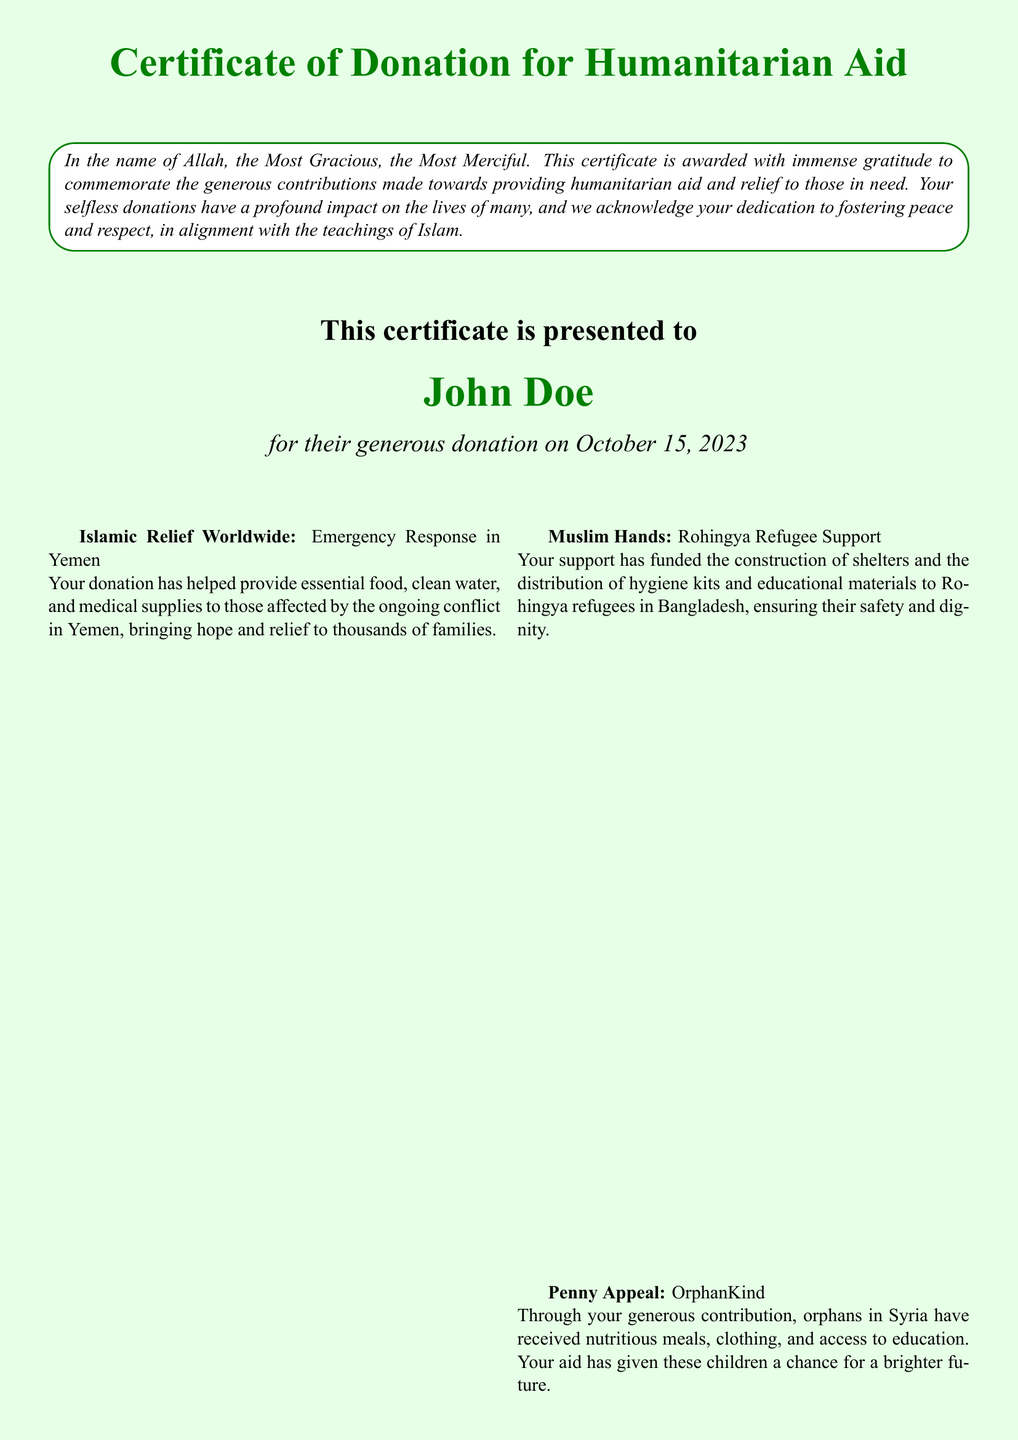What is the title of the certificate? The title of the certificate is stated at the top of the document.
Answer: Certificate of Donation for Humanitarian Aid Who is the certificate presented to? The recipient of the certificate is specified in the document.
Answer: John Doe What is the date of the donation? The date when the donation was made is mentioned in the certificate.
Answer: October 15, 2023 Which organization provided emergency response in Yemen? The document lists organizations involved in various humanitarian projects, including one for Yemen.
Answer: Islamic Relief Worldwide What project did Muslim Hands support? The document details specific humanitarian projects supported by donations.
Answer: Rohingya Refugee Support What type of support did Penny Appeal provide? The document describes the humanitarian aid provided to orphans through Penny Appeal.
Answer: OrphanKind What is one item provided to vulnerable families during winter by Human Appeal? The document mentions the aid provided by Human Appeal during winter for families.
Answer: Warm clothing What is the closing message of the certificate? The final part of the document includes a message wishing blessings upon the recipient.
Answer: May Allah bless you for your kindness Who is the representative signature for the charity organization? The document includes a placeholder for the representative of the charity organization.
Answer: Charity Organization Representative 